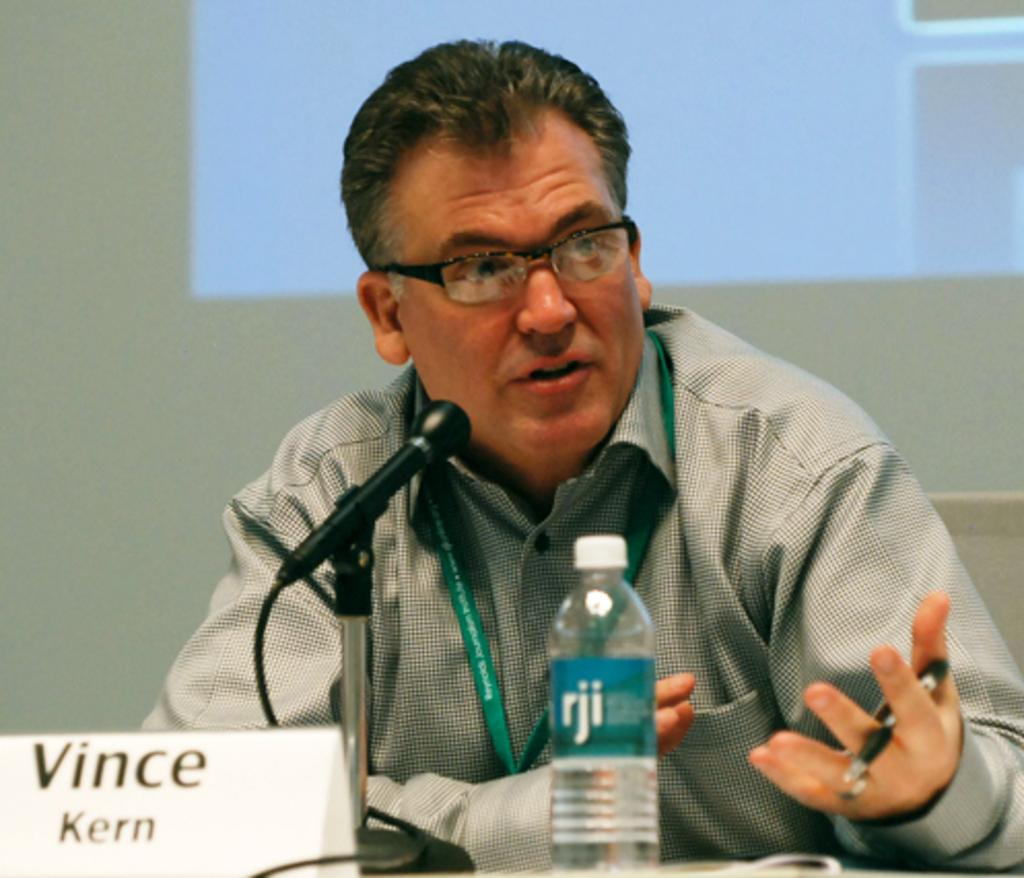Who is the person in the image? There is a man in the image. What is the man doing in the image? The man is sitting on a table chair and speaking on a microphone. What is placed in front of the man? There is a bottle in front of the man. What type of receipt can be seen in the man's hand in the image? There is no receipt present in the man's hand or in the image. 